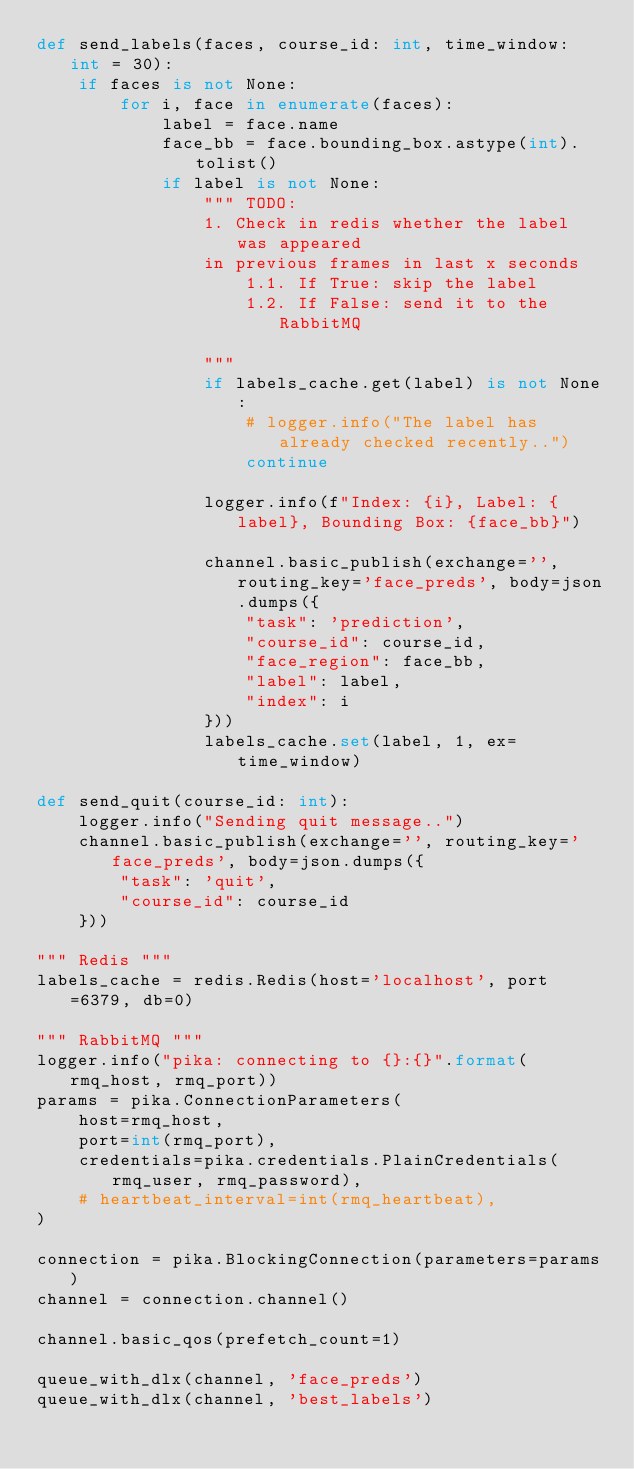<code> <loc_0><loc_0><loc_500><loc_500><_Python_>def send_labels(faces, course_id: int, time_window: int = 30):
    if faces is not None:
        for i, face in enumerate(faces):
            label = face.name
            face_bb = face.bounding_box.astype(int).tolist()
            if label is not None:
                """ TODO:
                1. Check in redis whether the label was appeared
                in previous frames in last x seconds
                    1.1. If True: skip the label
                    1.2. If False: send it to the RabbitMQ

                """
                if labels_cache.get(label) is not None:
                    # logger.info("The label has already checked recently..")
                    continue

                logger.info(f"Index: {i}, Label: {label}, Bounding Box: {face_bb}")

                channel.basic_publish(exchange='', routing_key='face_preds', body=json.dumps({
                    "task": 'prediction',
                    "course_id": course_id,
                    "face_region": face_bb,
                    "label": label,
                    "index": i
                }))
                labels_cache.set(label, 1, ex=time_window)

def send_quit(course_id: int):
    logger.info("Sending quit message..")
    channel.basic_publish(exchange='', routing_key='face_preds', body=json.dumps({
        "task": 'quit',
        "course_id": course_id
    }))

""" Redis """
labels_cache = redis.Redis(host='localhost', port=6379, db=0)

""" RabbitMQ """
logger.info("pika: connecting to {}:{}".format(rmq_host, rmq_port))
params = pika.ConnectionParameters(
    host=rmq_host,
    port=int(rmq_port),
    credentials=pika.credentials.PlainCredentials(rmq_user, rmq_password),
    # heartbeat_interval=int(rmq_heartbeat),
)

connection = pika.BlockingConnection(parameters=params)
channel = connection.channel()

channel.basic_qos(prefetch_count=1)

queue_with_dlx(channel, 'face_preds')
queue_with_dlx(channel, 'best_labels')
</code> 